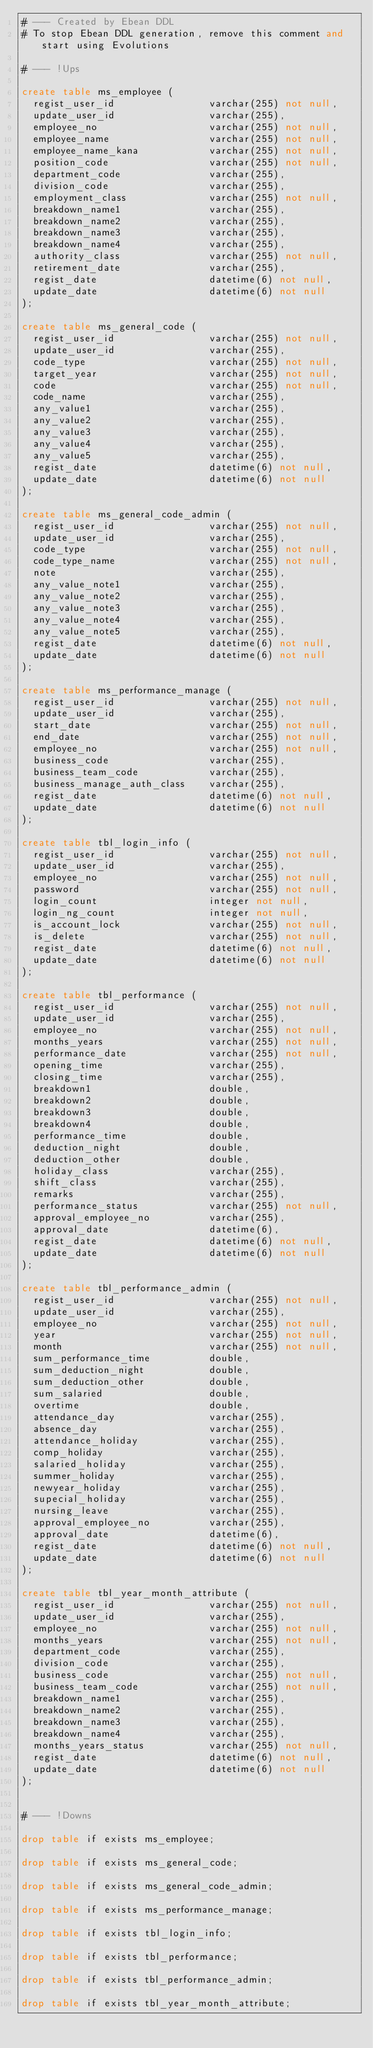<code> <loc_0><loc_0><loc_500><loc_500><_SQL_># --- Created by Ebean DDL
# To stop Ebean DDL generation, remove this comment and start using Evolutions

# --- !Ups

create table ms_employee (
  regist_user_id                varchar(255) not null,
  update_user_id                varchar(255),
  employee_no                   varchar(255) not null,
  employee_name                 varchar(255) not null,
  employee_name_kana            varchar(255) not null,
  position_code                 varchar(255) not null,
  department_code               varchar(255),
  division_code                 varchar(255),
  employment_class              varchar(255) not null,
  breakdown_name1               varchar(255),
  breakdown_name2               varchar(255),
  breakdown_name3               varchar(255),
  breakdown_name4               varchar(255),
  authority_class               varchar(255) not null,
  retirement_date               varchar(255),
  regist_date                   datetime(6) not null,
  update_date                   datetime(6) not null
);

create table ms_general_code (
  regist_user_id                varchar(255) not null,
  update_user_id                varchar(255),
  code_type                     varchar(255) not null,
  target_year                   varchar(255) not null,
  code                          varchar(255) not null,
  code_name                     varchar(255),
  any_value1                    varchar(255),
  any_value2                    varchar(255),
  any_value3                    varchar(255),
  any_value4                    varchar(255),
  any_value5                    varchar(255),
  regist_date                   datetime(6) not null,
  update_date                   datetime(6) not null
);

create table ms_general_code_admin (
  regist_user_id                varchar(255) not null,
  update_user_id                varchar(255),
  code_type                     varchar(255) not null,
  code_type_name                varchar(255) not null,
  note                          varchar(255),
  any_value_note1               varchar(255),
  any_value_note2               varchar(255),
  any_value_note3               varchar(255),
  any_value_note4               varchar(255),
  any_value_note5               varchar(255),
  regist_date                   datetime(6) not null,
  update_date                   datetime(6) not null
);

create table ms_performance_manage (
  regist_user_id                varchar(255) not null,
  update_user_id                varchar(255),
  start_date                    varchar(255) not null,
  end_date                      varchar(255) not null,
  employee_no                   varchar(255) not null,
  business_code                 varchar(255),
  business_team_code            varchar(255),
  business_manage_auth_class    varchar(255),
  regist_date                   datetime(6) not null,
  update_date                   datetime(6) not null
);

create table tbl_login_info (
  regist_user_id                varchar(255) not null,
  update_user_id                varchar(255),
  employee_no                   varchar(255) not null,
  password                      varchar(255) not null,
  login_count                   integer not null,
  login_ng_count                integer not null,
  is_account_lock               varchar(255) not null,
  is_delete                     varchar(255) not null,
  regist_date                   datetime(6) not null,
  update_date                   datetime(6) not null
);

create table tbl_performance (
  regist_user_id                varchar(255) not null,
  update_user_id                varchar(255),
  employee_no                   varchar(255) not null,
  months_years                  varchar(255) not null,
  performance_date              varchar(255) not null,
  opening_time                  varchar(255),
  closing_time                  varchar(255),
  breakdown1                    double,
  breakdown2                    double,
  breakdown3                    double,
  breakdown4                    double,
  performance_time              double,
  deduction_night               double,
  deduction_other               double,
  holiday_class                 varchar(255),
  shift_class                   varchar(255),
  remarks                       varchar(255),
  performance_status            varchar(255) not null,
  approval_employee_no          varchar(255),
  approval_date                 datetime(6),
  regist_date                   datetime(6) not null,
  update_date                   datetime(6) not null
);

create table tbl_performance_admin (
  regist_user_id                varchar(255) not null,
  update_user_id                varchar(255),
  employee_no                   varchar(255) not null,
  year                          varchar(255) not null,
  month                         varchar(255) not null,
  sum_performance_time          double,
  sum_deduction_night           double,
  sum_deduction_other           double,
  sum_salaried                  double,
  overtime                      double,
  attendance_day                varchar(255),
  absence_day                   varchar(255),
  attendance_holiday            varchar(255),
  comp_holiday                  varchar(255),
  salaried_holiday              varchar(255),
  summer_holiday                varchar(255),
  newyear_holiday               varchar(255),
  supecial_holiday              varchar(255),
  nursing_leave                 varchar(255),
  approval_employee_no          varchar(255),
  approval_date                 datetime(6),
  regist_date                   datetime(6) not null,
  update_date                   datetime(6) not null
);

create table tbl_year_month_attribute (
  regist_user_id                varchar(255) not null,
  update_user_id                varchar(255),
  employee_no                   varchar(255) not null,
  months_years                  varchar(255) not null,
  department_code               varchar(255),
  division_code                 varchar(255),
  business_code                 varchar(255) not null,
  business_team_code            varchar(255) not null,
  breakdown_name1               varchar(255),
  breakdown_name2               varchar(255),
  breakdown_name3               varchar(255),
  breakdown_name4               varchar(255),
  months_years_status           varchar(255) not null,
  regist_date                   datetime(6) not null,
  update_date                   datetime(6) not null
);


# --- !Downs

drop table if exists ms_employee;

drop table if exists ms_general_code;

drop table if exists ms_general_code_admin;

drop table if exists ms_performance_manage;

drop table if exists tbl_login_info;

drop table if exists tbl_performance;

drop table if exists tbl_performance_admin;

drop table if exists tbl_year_month_attribute;

</code> 